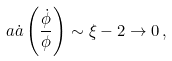<formula> <loc_0><loc_0><loc_500><loc_500>a \dot { a } \left ( \frac { \dot { \phi } } { \phi } \right ) \sim \xi - 2 \rightarrow 0 \, ,</formula> 